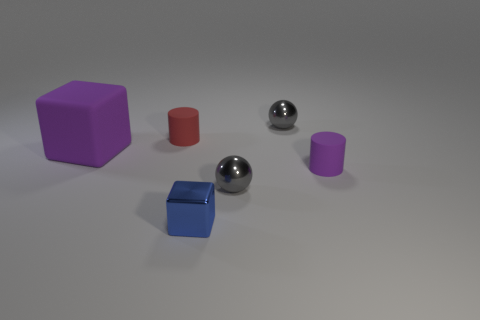What materials do the objects in the image appear to be made of? The objects in the image seem to be rendered digitally and designed to mimic various materials. The two spheres have reflective surfaces that resemble metal, while the cubes and cylinders appear to have matte surfaces, which could be interpreted as plastic or painted wood in a real-life scenario. 